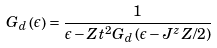Convert formula to latex. <formula><loc_0><loc_0><loc_500><loc_500>G _ { d } \left ( \epsilon \right ) = \frac { 1 } { \epsilon - Z t ^ { 2 } G _ { d } \left ( \epsilon - J ^ { z } Z / 2 \right ) }</formula> 